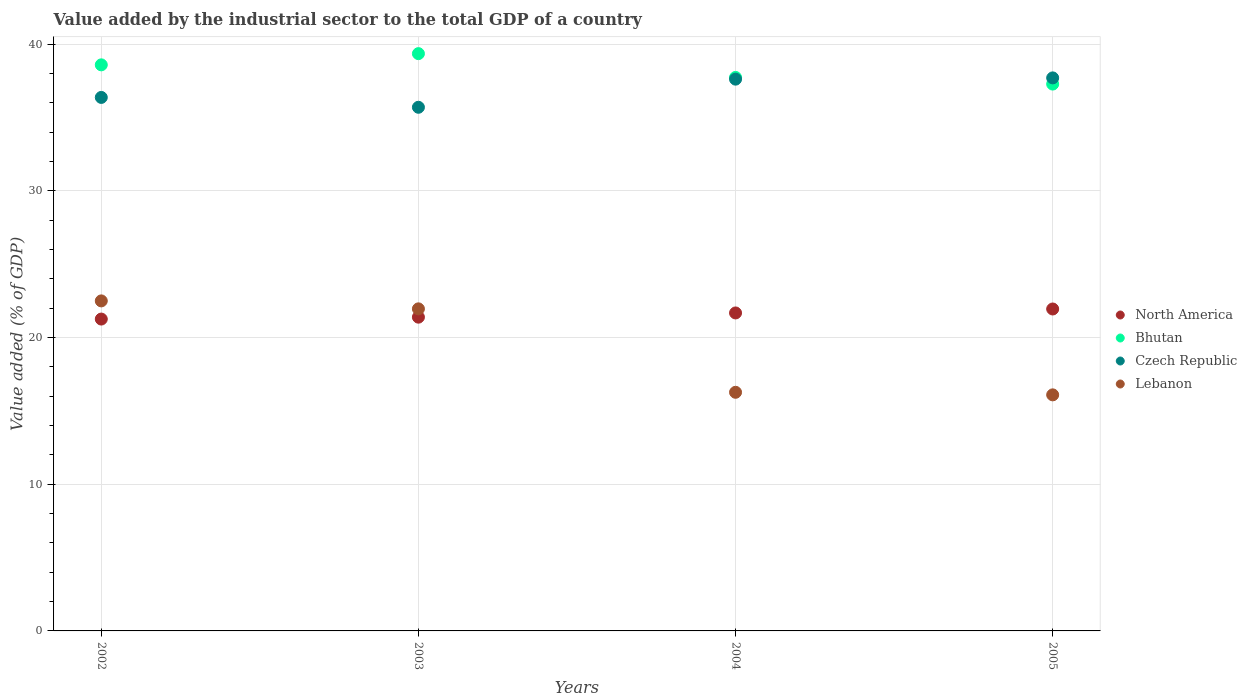How many different coloured dotlines are there?
Keep it short and to the point. 4. Is the number of dotlines equal to the number of legend labels?
Your response must be concise. Yes. What is the value added by the industrial sector to the total GDP in Czech Republic in 2002?
Give a very brief answer. 36.38. Across all years, what is the maximum value added by the industrial sector to the total GDP in Czech Republic?
Ensure brevity in your answer.  37.71. Across all years, what is the minimum value added by the industrial sector to the total GDP in Czech Republic?
Give a very brief answer. 35.71. What is the total value added by the industrial sector to the total GDP in Lebanon in the graph?
Your response must be concise. 76.84. What is the difference between the value added by the industrial sector to the total GDP in North America in 2003 and that in 2004?
Offer a terse response. -0.29. What is the difference between the value added by the industrial sector to the total GDP in Bhutan in 2002 and the value added by the industrial sector to the total GDP in Lebanon in 2003?
Provide a short and direct response. 16.64. What is the average value added by the industrial sector to the total GDP in Bhutan per year?
Provide a succinct answer. 38.25. In the year 2003, what is the difference between the value added by the industrial sector to the total GDP in North America and value added by the industrial sector to the total GDP in Czech Republic?
Make the answer very short. -14.31. In how many years, is the value added by the industrial sector to the total GDP in North America greater than 20 %?
Offer a terse response. 4. What is the ratio of the value added by the industrial sector to the total GDP in Lebanon in 2002 to that in 2003?
Give a very brief answer. 1.02. Is the difference between the value added by the industrial sector to the total GDP in North America in 2002 and 2005 greater than the difference between the value added by the industrial sector to the total GDP in Czech Republic in 2002 and 2005?
Your response must be concise. Yes. What is the difference between the highest and the second highest value added by the industrial sector to the total GDP in Bhutan?
Your answer should be very brief. 0.76. What is the difference between the highest and the lowest value added by the industrial sector to the total GDP in Czech Republic?
Offer a terse response. 2. In how many years, is the value added by the industrial sector to the total GDP in Czech Republic greater than the average value added by the industrial sector to the total GDP in Czech Republic taken over all years?
Offer a terse response. 2. Is the sum of the value added by the industrial sector to the total GDP in Bhutan in 2004 and 2005 greater than the maximum value added by the industrial sector to the total GDP in Czech Republic across all years?
Provide a short and direct response. Yes. Is it the case that in every year, the sum of the value added by the industrial sector to the total GDP in Lebanon and value added by the industrial sector to the total GDP in Bhutan  is greater than the value added by the industrial sector to the total GDP in North America?
Your response must be concise. Yes. Does the value added by the industrial sector to the total GDP in Bhutan monotonically increase over the years?
Your answer should be very brief. No. Is the value added by the industrial sector to the total GDP in Lebanon strictly greater than the value added by the industrial sector to the total GDP in North America over the years?
Make the answer very short. No. How many years are there in the graph?
Your answer should be very brief. 4. Does the graph contain any zero values?
Give a very brief answer. No. Does the graph contain grids?
Keep it short and to the point. Yes. How many legend labels are there?
Your response must be concise. 4. How are the legend labels stacked?
Ensure brevity in your answer.  Vertical. What is the title of the graph?
Make the answer very short. Value added by the industrial sector to the total GDP of a country. What is the label or title of the X-axis?
Ensure brevity in your answer.  Years. What is the label or title of the Y-axis?
Your response must be concise. Value added (% of GDP). What is the Value added (% of GDP) of North America in 2002?
Provide a short and direct response. 21.27. What is the Value added (% of GDP) in Bhutan in 2002?
Your answer should be compact. 38.6. What is the Value added (% of GDP) of Czech Republic in 2002?
Give a very brief answer. 36.38. What is the Value added (% of GDP) in Lebanon in 2002?
Provide a short and direct response. 22.5. What is the Value added (% of GDP) in North America in 2003?
Keep it short and to the point. 21.4. What is the Value added (% of GDP) in Bhutan in 2003?
Ensure brevity in your answer.  39.37. What is the Value added (% of GDP) in Czech Republic in 2003?
Make the answer very short. 35.71. What is the Value added (% of GDP) in Lebanon in 2003?
Offer a very short reply. 21.96. What is the Value added (% of GDP) of North America in 2004?
Your answer should be compact. 21.68. What is the Value added (% of GDP) in Bhutan in 2004?
Your answer should be very brief. 37.74. What is the Value added (% of GDP) in Czech Republic in 2004?
Your answer should be very brief. 37.63. What is the Value added (% of GDP) in Lebanon in 2004?
Your answer should be very brief. 16.27. What is the Value added (% of GDP) of North America in 2005?
Provide a succinct answer. 21.95. What is the Value added (% of GDP) of Bhutan in 2005?
Your answer should be very brief. 37.29. What is the Value added (% of GDP) in Czech Republic in 2005?
Provide a short and direct response. 37.71. What is the Value added (% of GDP) of Lebanon in 2005?
Offer a very short reply. 16.1. Across all years, what is the maximum Value added (% of GDP) in North America?
Make the answer very short. 21.95. Across all years, what is the maximum Value added (% of GDP) in Bhutan?
Ensure brevity in your answer.  39.37. Across all years, what is the maximum Value added (% of GDP) of Czech Republic?
Your response must be concise. 37.71. Across all years, what is the maximum Value added (% of GDP) of Lebanon?
Give a very brief answer. 22.5. Across all years, what is the minimum Value added (% of GDP) of North America?
Provide a short and direct response. 21.27. Across all years, what is the minimum Value added (% of GDP) of Bhutan?
Make the answer very short. 37.29. Across all years, what is the minimum Value added (% of GDP) of Czech Republic?
Your answer should be compact. 35.71. Across all years, what is the minimum Value added (% of GDP) in Lebanon?
Give a very brief answer. 16.1. What is the total Value added (% of GDP) in North America in the graph?
Make the answer very short. 86.3. What is the total Value added (% of GDP) in Bhutan in the graph?
Your response must be concise. 153. What is the total Value added (% of GDP) of Czech Republic in the graph?
Make the answer very short. 147.42. What is the total Value added (% of GDP) of Lebanon in the graph?
Your response must be concise. 76.84. What is the difference between the Value added (% of GDP) of North America in 2002 and that in 2003?
Your answer should be very brief. -0.13. What is the difference between the Value added (% of GDP) of Bhutan in 2002 and that in 2003?
Your answer should be very brief. -0.76. What is the difference between the Value added (% of GDP) of Czech Republic in 2002 and that in 2003?
Offer a very short reply. 0.67. What is the difference between the Value added (% of GDP) of Lebanon in 2002 and that in 2003?
Provide a succinct answer. 0.54. What is the difference between the Value added (% of GDP) in North America in 2002 and that in 2004?
Offer a terse response. -0.42. What is the difference between the Value added (% of GDP) in Bhutan in 2002 and that in 2004?
Make the answer very short. 0.86. What is the difference between the Value added (% of GDP) of Czech Republic in 2002 and that in 2004?
Your response must be concise. -1.25. What is the difference between the Value added (% of GDP) of Lebanon in 2002 and that in 2004?
Offer a very short reply. 6.23. What is the difference between the Value added (% of GDP) in North America in 2002 and that in 2005?
Your answer should be very brief. -0.69. What is the difference between the Value added (% of GDP) of Bhutan in 2002 and that in 2005?
Offer a very short reply. 1.31. What is the difference between the Value added (% of GDP) of Czech Republic in 2002 and that in 2005?
Offer a very short reply. -1.33. What is the difference between the Value added (% of GDP) of Lebanon in 2002 and that in 2005?
Provide a succinct answer. 6.41. What is the difference between the Value added (% of GDP) in North America in 2003 and that in 2004?
Ensure brevity in your answer.  -0.29. What is the difference between the Value added (% of GDP) of Bhutan in 2003 and that in 2004?
Provide a succinct answer. 1.62. What is the difference between the Value added (% of GDP) of Czech Republic in 2003 and that in 2004?
Provide a short and direct response. -1.92. What is the difference between the Value added (% of GDP) in Lebanon in 2003 and that in 2004?
Your response must be concise. 5.69. What is the difference between the Value added (% of GDP) of North America in 2003 and that in 2005?
Provide a succinct answer. -0.56. What is the difference between the Value added (% of GDP) in Bhutan in 2003 and that in 2005?
Your response must be concise. 2.08. What is the difference between the Value added (% of GDP) of Czech Republic in 2003 and that in 2005?
Offer a terse response. -2. What is the difference between the Value added (% of GDP) in Lebanon in 2003 and that in 2005?
Provide a short and direct response. 5.87. What is the difference between the Value added (% of GDP) in North America in 2004 and that in 2005?
Your answer should be compact. -0.27. What is the difference between the Value added (% of GDP) in Bhutan in 2004 and that in 2005?
Give a very brief answer. 0.45. What is the difference between the Value added (% of GDP) of Czech Republic in 2004 and that in 2005?
Your answer should be very brief. -0.09. What is the difference between the Value added (% of GDP) of Lebanon in 2004 and that in 2005?
Your response must be concise. 0.17. What is the difference between the Value added (% of GDP) in North America in 2002 and the Value added (% of GDP) in Bhutan in 2003?
Your response must be concise. -18.1. What is the difference between the Value added (% of GDP) of North America in 2002 and the Value added (% of GDP) of Czech Republic in 2003?
Make the answer very short. -14.44. What is the difference between the Value added (% of GDP) of North America in 2002 and the Value added (% of GDP) of Lebanon in 2003?
Offer a very short reply. -0.7. What is the difference between the Value added (% of GDP) in Bhutan in 2002 and the Value added (% of GDP) in Czech Republic in 2003?
Provide a short and direct response. 2.89. What is the difference between the Value added (% of GDP) of Bhutan in 2002 and the Value added (% of GDP) of Lebanon in 2003?
Keep it short and to the point. 16.64. What is the difference between the Value added (% of GDP) of Czech Republic in 2002 and the Value added (% of GDP) of Lebanon in 2003?
Offer a terse response. 14.42. What is the difference between the Value added (% of GDP) in North America in 2002 and the Value added (% of GDP) in Bhutan in 2004?
Your answer should be compact. -16.48. What is the difference between the Value added (% of GDP) of North America in 2002 and the Value added (% of GDP) of Czech Republic in 2004?
Your answer should be compact. -16.36. What is the difference between the Value added (% of GDP) in North America in 2002 and the Value added (% of GDP) in Lebanon in 2004?
Offer a terse response. 4.99. What is the difference between the Value added (% of GDP) in Bhutan in 2002 and the Value added (% of GDP) in Czech Republic in 2004?
Your response must be concise. 0.98. What is the difference between the Value added (% of GDP) in Bhutan in 2002 and the Value added (% of GDP) in Lebanon in 2004?
Offer a terse response. 22.33. What is the difference between the Value added (% of GDP) in Czech Republic in 2002 and the Value added (% of GDP) in Lebanon in 2004?
Make the answer very short. 20.11. What is the difference between the Value added (% of GDP) in North America in 2002 and the Value added (% of GDP) in Bhutan in 2005?
Give a very brief answer. -16.02. What is the difference between the Value added (% of GDP) in North America in 2002 and the Value added (% of GDP) in Czech Republic in 2005?
Keep it short and to the point. -16.45. What is the difference between the Value added (% of GDP) in North America in 2002 and the Value added (% of GDP) in Lebanon in 2005?
Provide a succinct answer. 5.17. What is the difference between the Value added (% of GDP) of Bhutan in 2002 and the Value added (% of GDP) of Czech Republic in 2005?
Your answer should be compact. 0.89. What is the difference between the Value added (% of GDP) of Bhutan in 2002 and the Value added (% of GDP) of Lebanon in 2005?
Your response must be concise. 22.5. What is the difference between the Value added (% of GDP) in Czech Republic in 2002 and the Value added (% of GDP) in Lebanon in 2005?
Offer a terse response. 20.28. What is the difference between the Value added (% of GDP) of North America in 2003 and the Value added (% of GDP) of Bhutan in 2004?
Your answer should be compact. -16.35. What is the difference between the Value added (% of GDP) in North America in 2003 and the Value added (% of GDP) in Czech Republic in 2004?
Make the answer very short. -16.23. What is the difference between the Value added (% of GDP) of North America in 2003 and the Value added (% of GDP) of Lebanon in 2004?
Your answer should be very brief. 5.12. What is the difference between the Value added (% of GDP) of Bhutan in 2003 and the Value added (% of GDP) of Czech Republic in 2004?
Your answer should be very brief. 1.74. What is the difference between the Value added (% of GDP) in Bhutan in 2003 and the Value added (% of GDP) in Lebanon in 2004?
Make the answer very short. 23.09. What is the difference between the Value added (% of GDP) in Czech Republic in 2003 and the Value added (% of GDP) in Lebanon in 2004?
Your answer should be very brief. 19.44. What is the difference between the Value added (% of GDP) in North America in 2003 and the Value added (% of GDP) in Bhutan in 2005?
Your answer should be compact. -15.89. What is the difference between the Value added (% of GDP) in North America in 2003 and the Value added (% of GDP) in Czech Republic in 2005?
Ensure brevity in your answer.  -16.32. What is the difference between the Value added (% of GDP) of North America in 2003 and the Value added (% of GDP) of Lebanon in 2005?
Offer a very short reply. 5.3. What is the difference between the Value added (% of GDP) of Bhutan in 2003 and the Value added (% of GDP) of Czech Republic in 2005?
Give a very brief answer. 1.65. What is the difference between the Value added (% of GDP) of Bhutan in 2003 and the Value added (% of GDP) of Lebanon in 2005?
Keep it short and to the point. 23.27. What is the difference between the Value added (% of GDP) of Czech Republic in 2003 and the Value added (% of GDP) of Lebanon in 2005?
Make the answer very short. 19.61. What is the difference between the Value added (% of GDP) in North America in 2004 and the Value added (% of GDP) in Bhutan in 2005?
Make the answer very short. -15.61. What is the difference between the Value added (% of GDP) of North America in 2004 and the Value added (% of GDP) of Czech Republic in 2005?
Your answer should be compact. -16.03. What is the difference between the Value added (% of GDP) of North America in 2004 and the Value added (% of GDP) of Lebanon in 2005?
Keep it short and to the point. 5.59. What is the difference between the Value added (% of GDP) of Bhutan in 2004 and the Value added (% of GDP) of Czech Republic in 2005?
Keep it short and to the point. 0.03. What is the difference between the Value added (% of GDP) in Bhutan in 2004 and the Value added (% of GDP) in Lebanon in 2005?
Offer a terse response. 21.65. What is the difference between the Value added (% of GDP) of Czech Republic in 2004 and the Value added (% of GDP) of Lebanon in 2005?
Offer a very short reply. 21.53. What is the average Value added (% of GDP) of North America per year?
Your answer should be compact. 21.57. What is the average Value added (% of GDP) in Bhutan per year?
Ensure brevity in your answer.  38.25. What is the average Value added (% of GDP) in Czech Republic per year?
Provide a succinct answer. 36.86. What is the average Value added (% of GDP) of Lebanon per year?
Offer a very short reply. 19.21. In the year 2002, what is the difference between the Value added (% of GDP) of North America and Value added (% of GDP) of Bhutan?
Make the answer very short. -17.34. In the year 2002, what is the difference between the Value added (% of GDP) of North America and Value added (% of GDP) of Czech Republic?
Keep it short and to the point. -15.11. In the year 2002, what is the difference between the Value added (% of GDP) of North America and Value added (% of GDP) of Lebanon?
Offer a terse response. -1.24. In the year 2002, what is the difference between the Value added (% of GDP) of Bhutan and Value added (% of GDP) of Czech Republic?
Give a very brief answer. 2.22. In the year 2002, what is the difference between the Value added (% of GDP) in Bhutan and Value added (% of GDP) in Lebanon?
Offer a very short reply. 16.1. In the year 2002, what is the difference between the Value added (% of GDP) of Czech Republic and Value added (% of GDP) of Lebanon?
Your answer should be very brief. 13.87. In the year 2003, what is the difference between the Value added (% of GDP) of North America and Value added (% of GDP) of Bhutan?
Provide a succinct answer. -17.97. In the year 2003, what is the difference between the Value added (% of GDP) in North America and Value added (% of GDP) in Czech Republic?
Your answer should be compact. -14.31. In the year 2003, what is the difference between the Value added (% of GDP) of North America and Value added (% of GDP) of Lebanon?
Your answer should be compact. -0.57. In the year 2003, what is the difference between the Value added (% of GDP) in Bhutan and Value added (% of GDP) in Czech Republic?
Give a very brief answer. 3.66. In the year 2003, what is the difference between the Value added (% of GDP) in Bhutan and Value added (% of GDP) in Lebanon?
Your answer should be compact. 17.4. In the year 2003, what is the difference between the Value added (% of GDP) of Czech Republic and Value added (% of GDP) of Lebanon?
Provide a short and direct response. 13.74. In the year 2004, what is the difference between the Value added (% of GDP) in North America and Value added (% of GDP) in Bhutan?
Offer a very short reply. -16.06. In the year 2004, what is the difference between the Value added (% of GDP) in North America and Value added (% of GDP) in Czech Republic?
Provide a succinct answer. -15.94. In the year 2004, what is the difference between the Value added (% of GDP) of North America and Value added (% of GDP) of Lebanon?
Ensure brevity in your answer.  5.41. In the year 2004, what is the difference between the Value added (% of GDP) of Bhutan and Value added (% of GDP) of Czech Republic?
Ensure brevity in your answer.  0.12. In the year 2004, what is the difference between the Value added (% of GDP) in Bhutan and Value added (% of GDP) in Lebanon?
Make the answer very short. 21.47. In the year 2004, what is the difference between the Value added (% of GDP) of Czech Republic and Value added (% of GDP) of Lebanon?
Provide a succinct answer. 21.35. In the year 2005, what is the difference between the Value added (% of GDP) in North America and Value added (% of GDP) in Bhutan?
Keep it short and to the point. -15.34. In the year 2005, what is the difference between the Value added (% of GDP) in North America and Value added (% of GDP) in Czech Republic?
Your answer should be compact. -15.76. In the year 2005, what is the difference between the Value added (% of GDP) of North America and Value added (% of GDP) of Lebanon?
Give a very brief answer. 5.86. In the year 2005, what is the difference between the Value added (% of GDP) of Bhutan and Value added (% of GDP) of Czech Republic?
Give a very brief answer. -0.42. In the year 2005, what is the difference between the Value added (% of GDP) in Bhutan and Value added (% of GDP) in Lebanon?
Your answer should be compact. 21.19. In the year 2005, what is the difference between the Value added (% of GDP) of Czech Republic and Value added (% of GDP) of Lebanon?
Provide a short and direct response. 21.61. What is the ratio of the Value added (% of GDP) of Bhutan in 2002 to that in 2003?
Your answer should be very brief. 0.98. What is the ratio of the Value added (% of GDP) in Czech Republic in 2002 to that in 2003?
Provide a succinct answer. 1.02. What is the ratio of the Value added (% of GDP) of Lebanon in 2002 to that in 2003?
Your answer should be very brief. 1.02. What is the ratio of the Value added (% of GDP) of North America in 2002 to that in 2004?
Offer a very short reply. 0.98. What is the ratio of the Value added (% of GDP) of Bhutan in 2002 to that in 2004?
Provide a short and direct response. 1.02. What is the ratio of the Value added (% of GDP) of Czech Republic in 2002 to that in 2004?
Make the answer very short. 0.97. What is the ratio of the Value added (% of GDP) of Lebanon in 2002 to that in 2004?
Provide a short and direct response. 1.38. What is the ratio of the Value added (% of GDP) of North America in 2002 to that in 2005?
Offer a very short reply. 0.97. What is the ratio of the Value added (% of GDP) in Bhutan in 2002 to that in 2005?
Your response must be concise. 1.04. What is the ratio of the Value added (% of GDP) of Czech Republic in 2002 to that in 2005?
Offer a terse response. 0.96. What is the ratio of the Value added (% of GDP) in Lebanon in 2002 to that in 2005?
Keep it short and to the point. 1.4. What is the ratio of the Value added (% of GDP) in North America in 2003 to that in 2004?
Offer a very short reply. 0.99. What is the ratio of the Value added (% of GDP) of Bhutan in 2003 to that in 2004?
Ensure brevity in your answer.  1.04. What is the ratio of the Value added (% of GDP) of Czech Republic in 2003 to that in 2004?
Your answer should be very brief. 0.95. What is the ratio of the Value added (% of GDP) in Lebanon in 2003 to that in 2004?
Your answer should be very brief. 1.35. What is the ratio of the Value added (% of GDP) of North America in 2003 to that in 2005?
Your response must be concise. 0.97. What is the ratio of the Value added (% of GDP) in Bhutan in 2003 to that in 2005?
Provide a short and direct response. 1.06. What is the ratio of the Value added (% of GDP) in Czech Republic in 2003 to that in 2005?
Provide a short and direct response. 0.95. What is the ratio of the Value added (% of GDP) of Lebanon in 2003 to that in 2005?
Your response must be concise. 1.36. What is the ratio of the Value added (% of GDP) of Bhutan in 2004 to that in 2005?
Provide a succinct answer. 1.01. What is the ratio of the Value added (% of GDP) in Czech Republic in 2004 to that in 2005?
Your answer should be very brief. 1. What is the ratio of the Value added (% of GDP) of Lebanon in 2004 to that in 2005?
Provide a succinct answer. 1.01. What is the difference between the highest and the second highest Value added (% of GDP) in North America?
Provide a succinct answer. 0.27. What is the difference between the highest and the second highest Value added (% of GDP) in Bhutan?
Offer a terse response. 0.76. What is the difference between the highest and the second highest Value added (% of GDP) in Czech Republic?
Offer a terse response. 0.09. What is the difference between the highest and the second highest Value added (% of GDP) in Lebanon?
Ensure brevity in your answer.  0.54. What is the difference between the highest and the lowest Value added (% of GDP) in North America?
Make the answer very short. 0.69. What is the difference between the highest and the lowest Value added (% of GDP) in Bhutan?
Your response must be concise. 2.08. What is the difference between the highest and the lowest Value added (% of GDP) of Czech Republic?
Your response must be concise. 2. What is the difference between the highest and the lowest Value added (% of GDP) in Lebanon?
Make the answer very short. 6.41. 